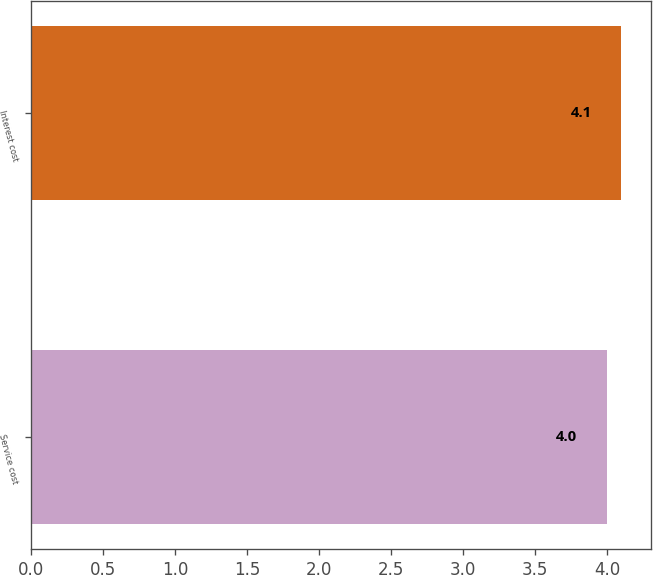Convert chart to OTSL. <chart><loc_0><loc_0><loc_500><loc_500><bar_chart><fcel>Service cost<fcel>Interest cost<nl><fcel>4<fcel>4.1<nl></chart> 